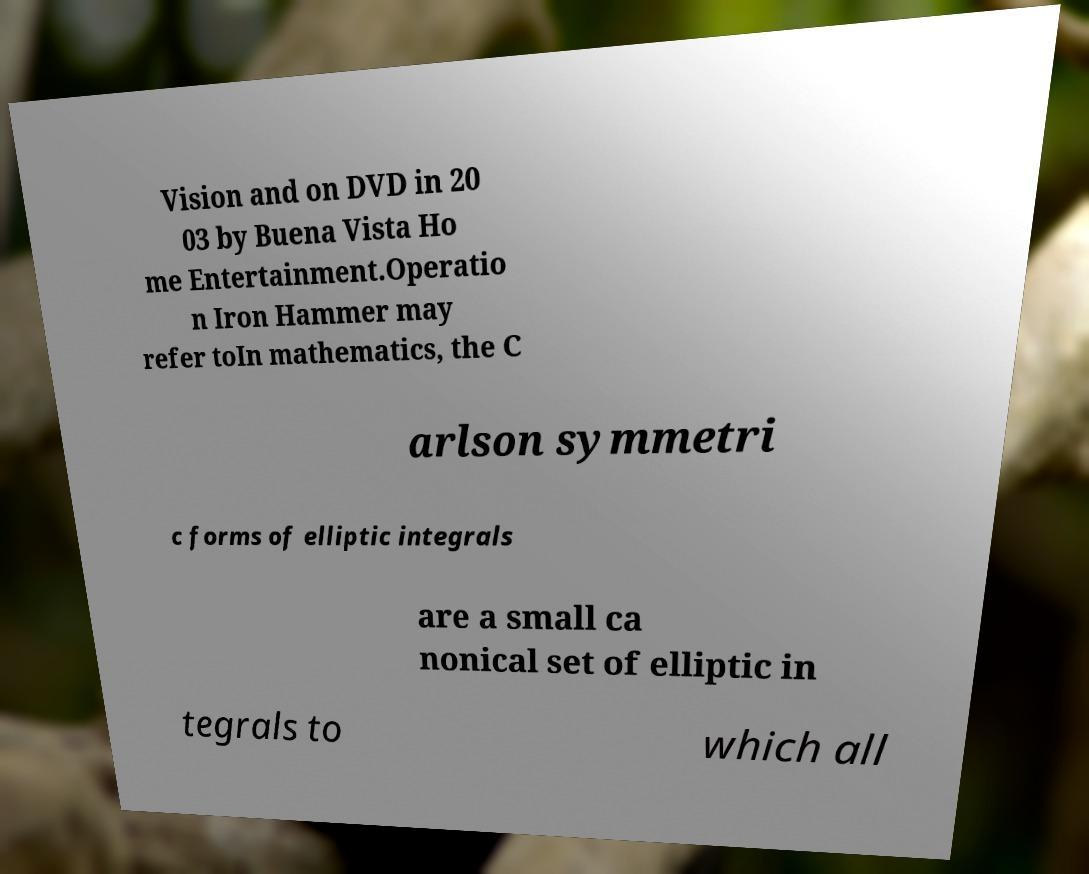I need the written content from this picture converted into text. Can you do that? Vision and on DVD in 20 03 by Buena Vista Ho me Entertainment.Operatio n Iron Hammer may refer toIn mathematics, the C arlson symmetri c forms of elliptic integrals are a small ca nonical set of elliptic in tegrals to which all 